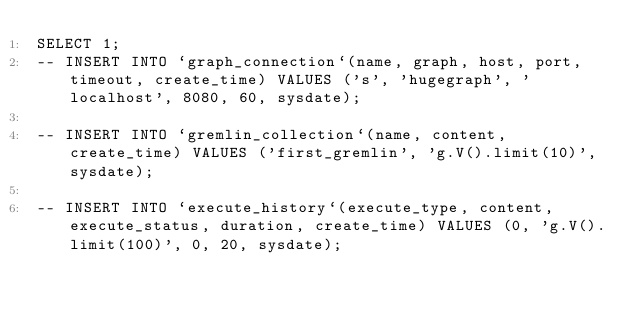<code> <loc_0><loc_0><loc_500><loc_500><_SQL_>SELECT 1;
-- INSERT INTO `graph_connection`(name, graph, host, port, timeout, create_time) VALUES ('s', 'hugegraph', 'localhost', 8080, 60, sysdate);

-- INSERT INTO `gremlin_collection`(name, content, create_time) VALUES ('first_gremlin', 'g.V().limit(10)', sysdate);

-- INSERT INTO `execute_history`(execute_type, content, execute_status, duration, create_time) VALUES (0, 'g.V().limit(100)', 0, 20, sysdate);
</code> 